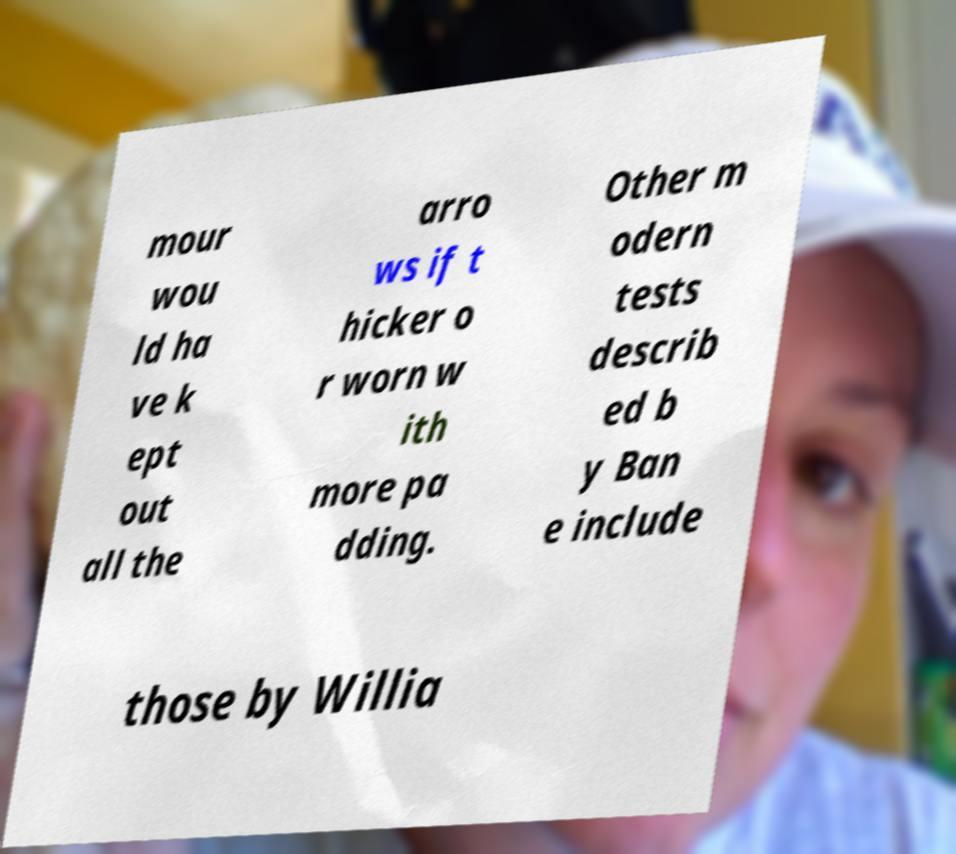Can you accurately transcribe the text from the provided image for me? mour wou ld ha ve k ept out all the arro ws if t hicker o r worn w ith more pa dding. Other m odern tests describ ed b y Ban e include those by Willia 